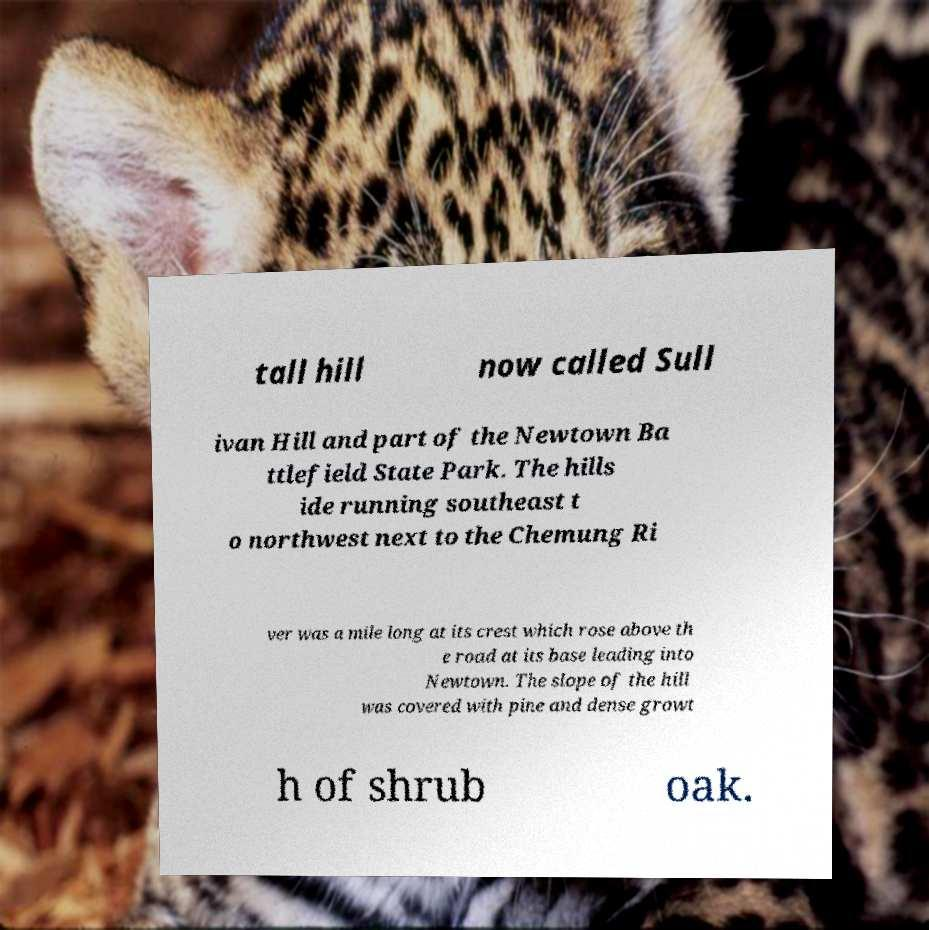Can you read and provide the text displayed in the image?This photo seems to have some interesting text. Can you extract and type it out for me? tall hill now called Sull ivan Hill and part of the Newtown Ba ttlefield State Park. The hills ide running southeast t o northwest next to the Chemung Ri ver was a mile long at its crest which rose above th e road at its base leading into Newtown. The slope of the hill was covered with pine and dense growt h of shrub oak. 